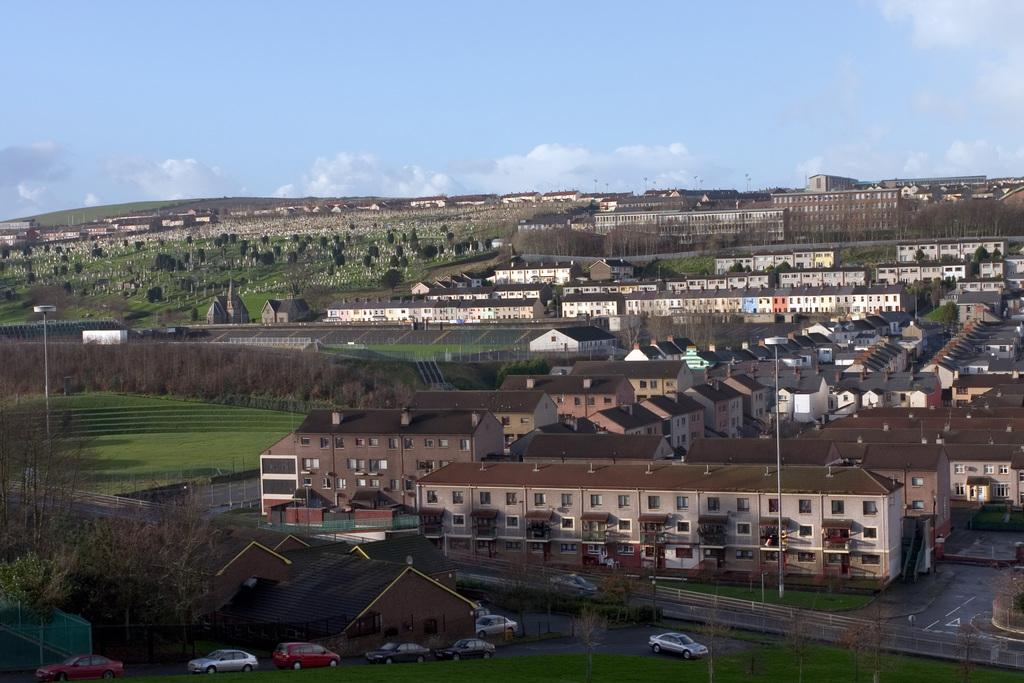What type of structures can be seen in the image? There are buildings in the image. What natural elements are present in the image? There are trees, mountains, and grass in the image. What man-made objects can be seen in the image? There are poles and fencing in the image. What is happening on the road in the image? There are vehicles on the road in the image. What part of the natural environment is visible in the image? The sky is visible in the image. Where is the grandmother in the image? There is no grandmother present in the image. What type of paste is being used to create the fencing in the image? There is no paste used in the fencing in the image; it is a separate structure. 